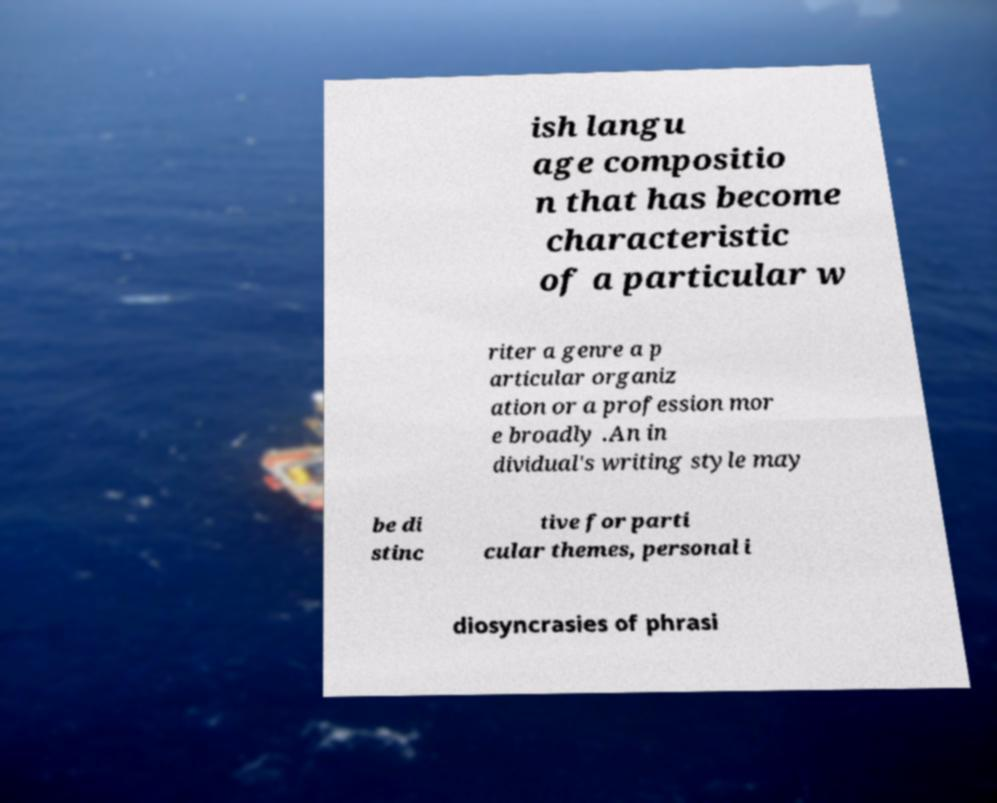Could you extract and type out the text from this image? ish langu age compositio n that has become characteristic of a particular w riter a genre a p articular organiz ation or a profession mor e broadly .An in dividual's writing style may be di stinc tive for parti cular themes, personal i diosyncrasies of phrasi 